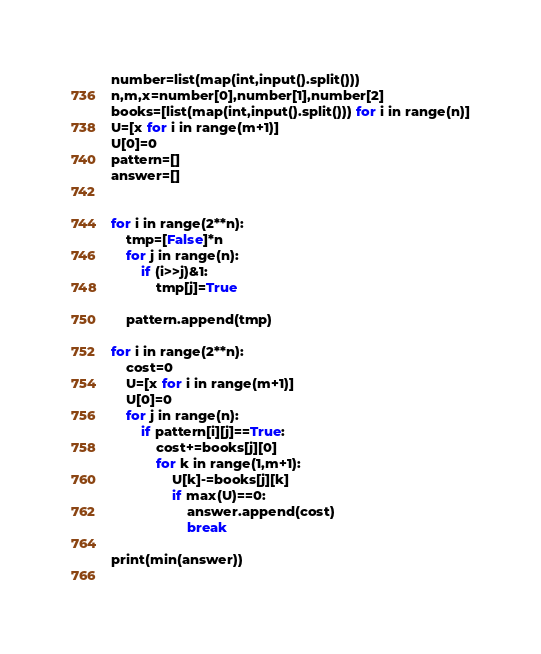Convert code to text. <code><loc_0><loc_0><loc_500><loc_500><_Python_>number=list(map(int,input().split()))
n,m,x=number[0],number[1],number[2]
books=[list(map(int,input().split())) for i in range(n)]
U=[x for i in range(m+1)]
U[0]=0
pattern=[]
answer=[]


for i in range(2**n):
    tmp=[False]*n
    for j in range(n):
        if (i>>j)&1:
            tmp[j]=True
    
    pattern.append(tmp)

for i in range(2**n):
    cost=0
    U=[x for i in range(m+1)]
    U[0]=0
    for j in range(n):
        if pattern[i][j]==True:
            cost+=books[j][0]
            for k in range(1,m+1):
                U[k]-=books[j][k]
                if max(U)==0:
                    answer.append(cost)
                    break
                    
print(min(answer))
                </code> 